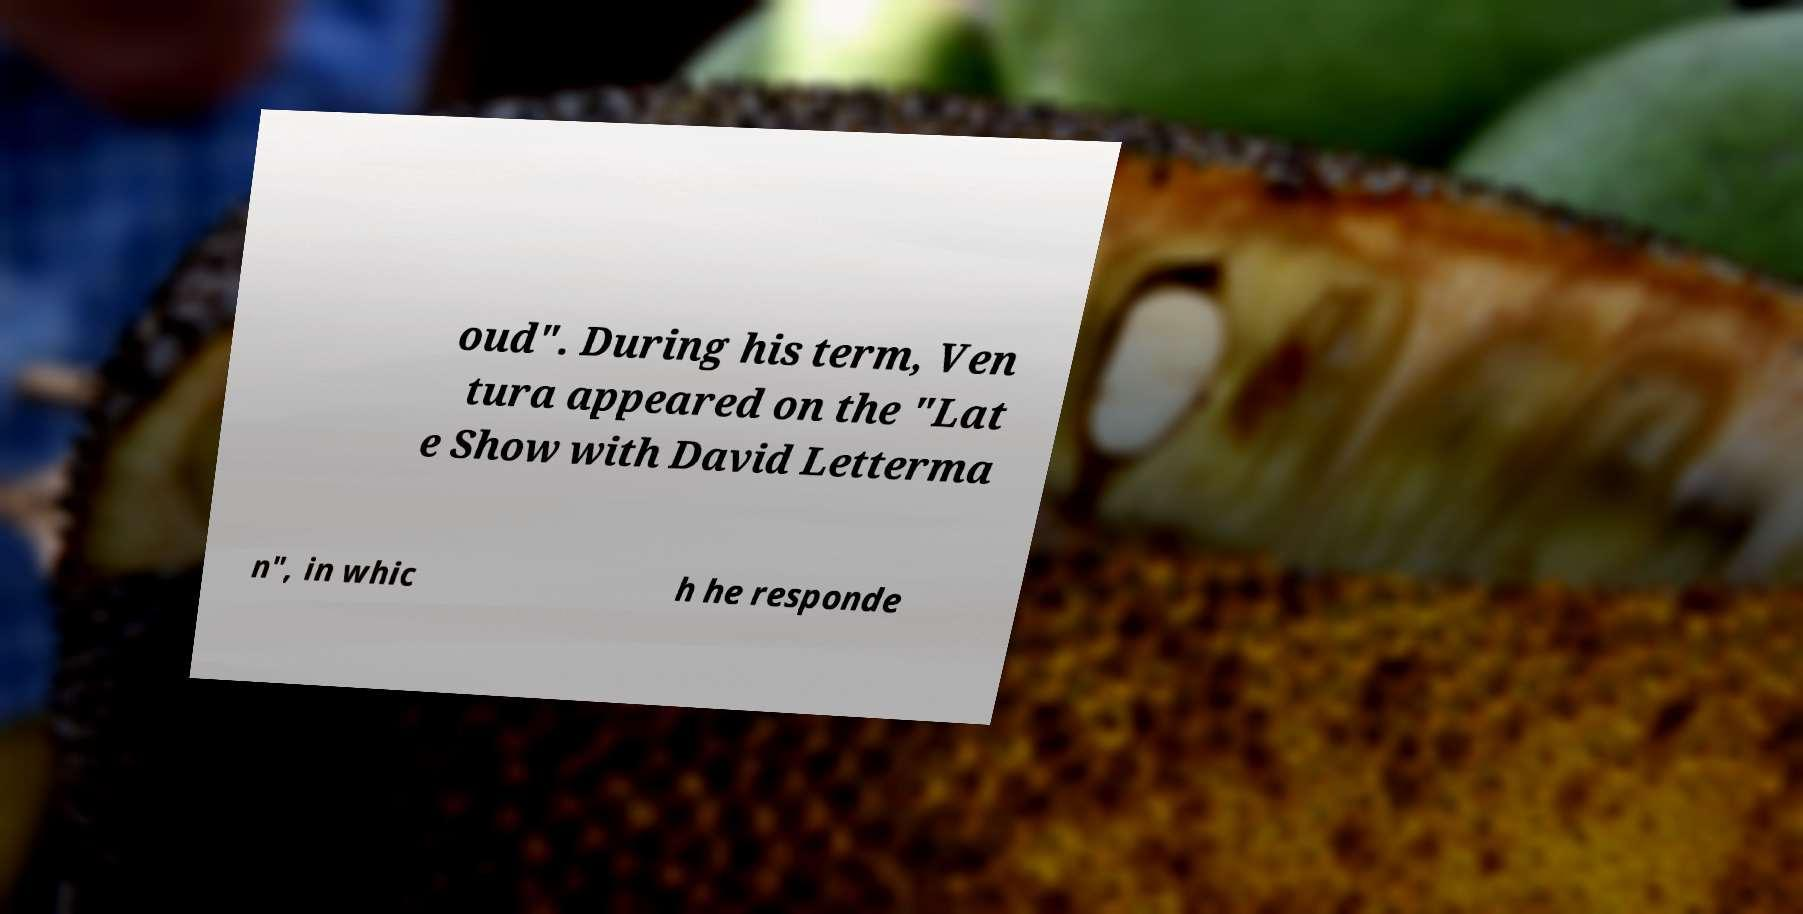Could you extract and type out the text from this image? oud". During his term, Ven tura appeared on the "Lat e Show with David Letterma n", in whic h he responde 